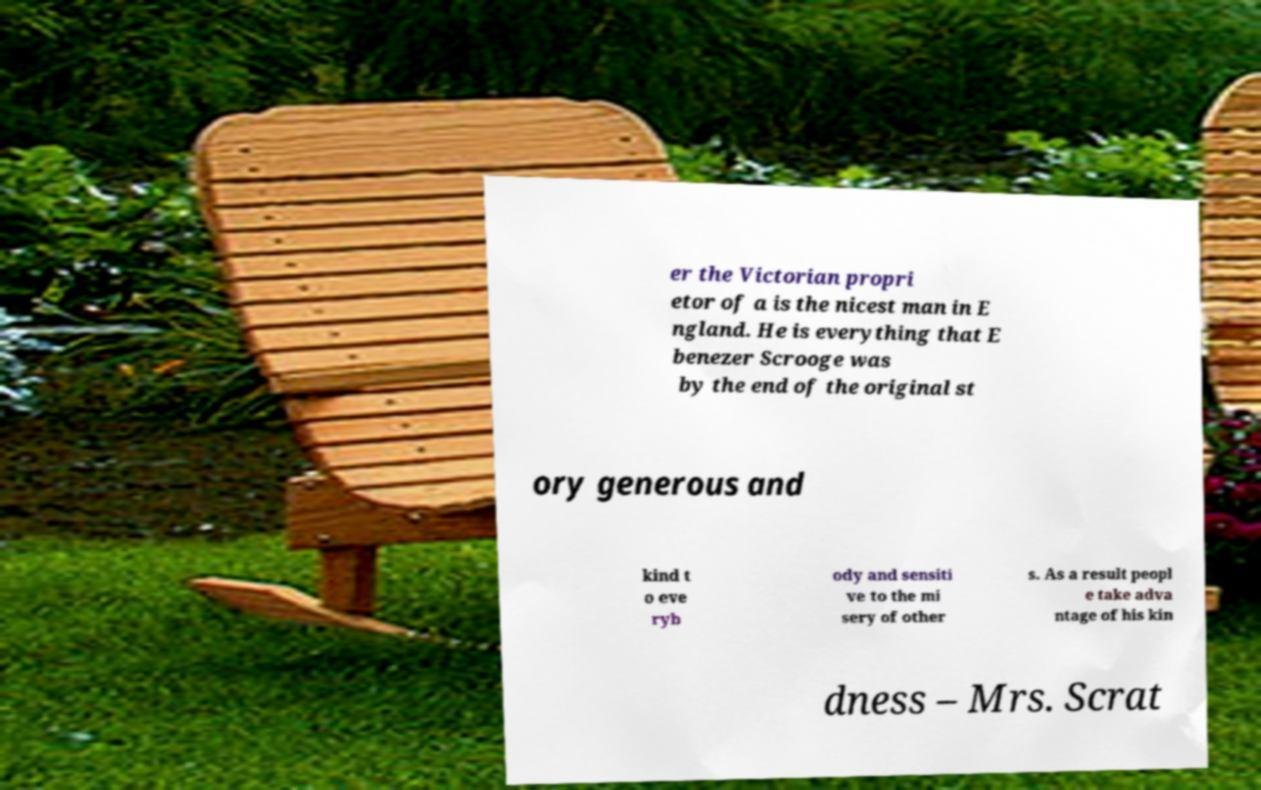I need the written content from this picture converted into text. Can you do that? er the Victorian propri etor of a is the nicest man in E ngland. He is everything that E benezer Scrooge was by the end of the original st ory generous and kind t o eve ryb ody and sensiti ve to the mi sery of other s. As a result peopl e take adva ntage of his kin dness – Mrs. Scrat 